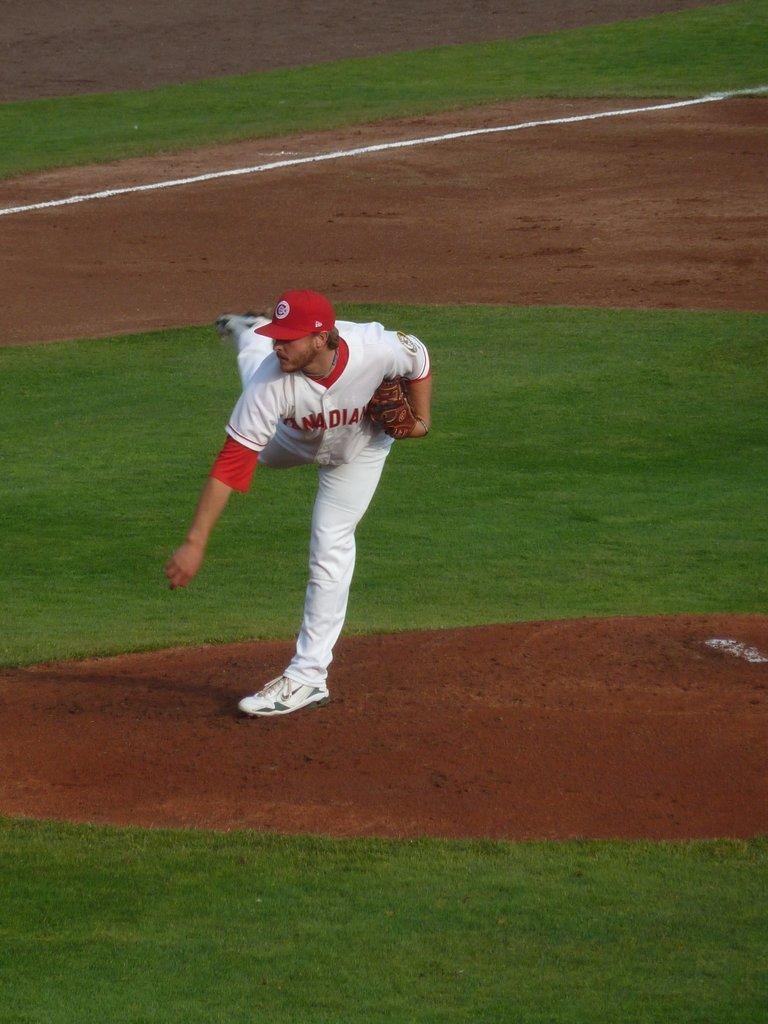<image>
Summarize the visual content of the image. The pitcher for the Canadian team has just thrown the ball. 